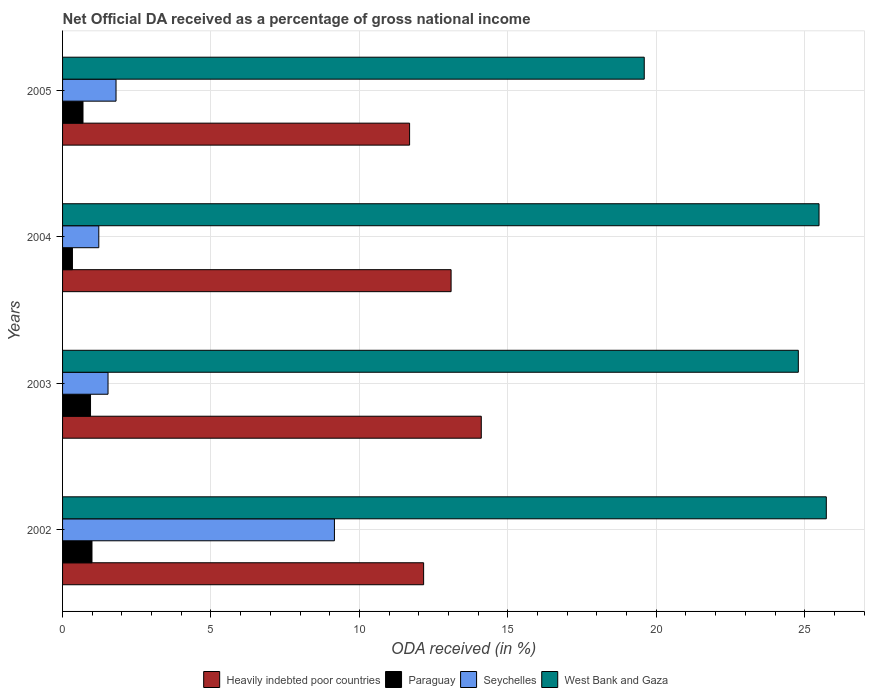How many different coloured bars are there?
Provide a succinct answer. 4. Are the number of bars per tick equal to the number of legend labels?
Offer a very short reply. Yes. Are the number of bars on each tick of the Y-axis equal?
Your answer should be compact. Yes. How many bars are there on the 4th tick from the top?
Provide a short and direct response. 4. In how many cases, is the number of bars for a given year not equal to the number of legend labels?
Make the answer very short. 0. What is the net official DA received in Heavily indebted poor countries in 2005?
Give a very brief answer. 11.69. Across all years, what is the maximum net official DA received in West Bank and Gaza?
Your response must be concise. 25.73. Across all years, what is the minimum net official DA received in Paraguay?
Your response must be concise. 0.33. In which year was the net official DA received in Heavily indebted poor countries maximum?
Your answer should be very brief. 2003. What is the total net official DA received in West Bank and Gaza in the graph?
Offer a terse response. 95.59. What is the difference between the net official DA received in Paraguay in 2002 and that in 2005?
Make the answer very short. 0.3. What is the difference between the net official DA received in West Bank and Gaza in 2004 and the net official DA received in Paraguay in 2003?
Ensure brevity in your answer.  24.54. What is the average net official DA received in Heavily indebted poor countries per year?
Make the answer very short. 12.76. In the year 2003, what is the difference between the net official DA received in Paraguay and net official DA received in Heavily indebted poor countries?
Offer a very short reply. -13.16. What is the ratio of the net official DA received in Paraguay in 2002 to that in 2004?
Your response must be concise. 2.98. Is the difference between the net official DA received in Paraguay in 2004 and 2005 greater than the difference between the net official DA received in Heavily indebted poor countries in 2004 and 2005?
Offer a terse response. No. What is the difference between the highest and the second highest net official DA received in Seychelles?
Give a very brief answer. 7.36. What is the difference between the highest and the lowest net official DA received in Heavily indebted poor countries?
Make the answer very short. 2.42. Is the sum of the net official DA received in Heavily indebted poor countries in 2003 and 2005 greater than the maximum net official DA received in West Bank and Gaza across all years?
Offer a very short reply. Yes. Is it the case that in every year, the sum of the net official DA received in Seychelles and net official DA received in Paraguay is greater than the sum of net official DA received in West Bank and Gaza and net official DA received in Heavily indebted poor countries?
Offer a terse response. No. What does the 2nd bar from the top in 2002 represents?
Make the answer very short. Seychelles. What does the 2nd bar from the bottom in 2004 represents?
Offer a very short reply. Paraguay. How many bars are there?
Provide a succinct answer. 16. How many years are there in the graph?
Make the answer very short. 4. What is the difference between two consecutive major ticks on the X-axis?
Ensure brevity in your answer.  5. Are the values on the major ticks of X-axis written in scientific E-notation?
Provide a succinct answer. No. Where does the legend appear in the graph?
Ensure brevity in your answer.  Bottom center. How many legend labels are there?
Provide a short and direct response. 4. What is the title of the graph?
Make the answer very short. Net Official DA received as a percentage of gross national income. Does "Cayman Islands" appear as one of the legend labels in the graph?
Your response must be concise. No. What is the label or title of the X-axis?
Provide a succinct answer. ODA received (in %). What is the ODA received (in %) of Heavily indebted poor countries in 2002?
Provide a succinct answer. 12.16. What is the ODA received (in %) in Paraguay in 2002?
Give a very brief answer. 0.99. What is the ODA received (in %) of Seychelles in 2002?
Give a very brief answer. 9.16. What is the ODA received (in %) of West Bank and Gaza in 2002?
Give a very brief answer. 25.73. What is the ODA received (in %) of Heavily indebted poor countries in 2003?
Make the answer very short. 14.11. What is the ODA received (in %) in Paraguay in 2003?
Offer a very short reply. 0.94. What is the ODA received (in %) of Seychelles in 2003?
Your answer should be compact. 1.53. What is the ODA received (in %) of West Bank and Gaza in 2003?
Provide a succinct answer. 24.79. What is the ODA received (in %) of Heavily indebted poor countries in 2004?
Ensure brevity in your answer.  13.09. What is the ODA received (in %) of Paraguay in 2004?
Your answer should be very brief. 0.33. What is the ODA received (in %) of Seychelles in 2004?
Offer a terse response. 1.22. What is the ODA received (in %) of West Bank and Gaza in 2004?
Make the answer very short. 25.48. What is the ODA received (in %) in Heavily indebted poor countries in 2005?
Keep it short and to the point. 11.69. What is the ODA received (in %) in Paraguay in 2005?
Offer a terse response. 0.69. What is the ODA received (in %) of Seychelles in 2005?
Your answer should be compact. 1.8. What is the ODA received (in %) in West Bank and Gaza in 2005?
Give a very brief answer. 19.6. Across all years, what is the maximum ODA received (in %) of Heavily indebted poor countries?
Provide a succinct answer. 14.11. Across all years, what is the maximum ODA received (in %) of Paraguay?
Provide a short and direct response. 0.99. Across all years, what is the maximum ODA received (in %) of Seychelles?
Your answer should be compact. 9.16. Across all years, what is the maximum ODA received (in %) in West Bank and Gaza?
Your answer should be very brief. 25.73. Across all years, what is the minimum ODA received (in %) in Heavily indebted poor countries?
Your answer should be compact. 11.69. Across all years, what is the minimum ODA received (in %) of Paraguay?
Make the answer very short. 0.33. Across all years, what is the minimum ODA received (in %) in Seychelles?
Ensure brevity in your answer.  1.22. Across all years, what is the minimum ODA received (in %) in West Bank and Gaza?
Provide a short and direct response. 19.6. What is the total ODA received (in %) in Heavily indebted poor countries in the graph?
Your response must be concise. 51.05. What is the total ODA received (in %) of Paraguay in the graph?
Provide a succinct answer. 2.95. What is the total ODA received (in %) of Seychelles in the graph?
Offer a terse response. 13.71. What is the total ODA received (in %) of West Bank and Gaza in the graph?
Your answer should be compact. 95.59. What is the difference between the ODA received (in %) of Heavily indebted poor countries in 2002 and that in 2003?
Provide a succinct answer. -1.94. What is the difference between the ODA received (in %) in Paraguay in 2002 and that in 2003?
Keep it short and to the point. 0.05. What is the difference between the ODA received (in %) in Seychelles in 2002 and that in 2003?
Provide a succinct answer. 7.63. What is the difference between the ODA received (in %) in West Bank and Gaza in 2002 and that in 2003?
Your answer should be very brief. 0.94. What is the difference between the ODA received (in %) of Heavily indebted poor countries in 2002 and that in 2004?
Your response must be concise. -0.93. What is the difference between the ODA received (in %) in Paraguay in 2002 and that in 2004?
Provide a succinct answer. 0.66. What is the difference between the ODA received (in %) in Seychelles in 2002 and that in 2004?
Ensure brevity in your answer.  7.94. What is the difference between the ODA received (in %) of West Bank and Gaza in 2002 and that in 2004?
Provide a short and direct response. 0.25. What is the difference between the ODA received (in %) of Heavily indebted poor countries in 2002 and that in 2005?
Keep it short and to the point. 0.47. What is the difference between the ODA received (in %) of Paraguay in 2002 and that in 2005?
Make the answer very short. 0.3. What is the difference between the ODA received (in %) in Seychelles in 2002 and that in 2005?
Offer a very short reply. 7.36. What is the difference between the ODA received (in %) of West Bank and Gaza in 2002 and that in 2005?
Offer a terse response. 6.13. What is the difference between the ODA received (in %) in Heavily indebted poor countries in 2003 and that in 2004?
Offer a very short reply. 1.02. What is the difference between the ODA received (in %) in Paraguay in 2003 and that in 2004?
Make the answer very short. 0.61. What is the difference between the ODA received (in %) of Seychelles in 2003 and that in 2004?
Your answer should be compact. 0.31. What is the difference between the ODA received (in %) in West Bank and Gaza in 2003 and that in 2004?
Give a very brief answer. -0.7. What is the difference between the ODA received (in %) in Heavily indebted poor countries in 2003 and that in 2005?
Offer a terse response. 2.42. What is the difference between the ODA received (in %) of Paraguay in 2003 and that in 2005?
Keep it short and to the point. 0.25. What is the difference between the ODA received (in %) in Seychelles in 2003 and that in 2005?
Offer a very short reply. -0.27. What is the difference between the ODA received (in %) in West Bank and Gaza in 2003 and that in 2005?
Ensure brevity in your answer.  5.19. What is the difference between the ODA received (in %) of Heavily indebted poor countries in 2004 and that in 2005?
Provide a short and direct response. 1.4. What is the difference between the ODA received (in %) of Paraguay in 2004 and that in 2005?
Ensure brevity in your answer.  -0.36. What is the difference between the ODA received (in %) in Seychelles in 2004 and that in 2005?
Ensure brevity in your answer.  -0.58. What is the difference between the ODA received (in %) of West Bank and Gaza in 2004 and that in 2005?
Provide a succinct answer. 5.89. What is the difference between the ODA received (in %) of Heavily indebted poor countries in 2002 and the ODA received (in %) of Paraguay in 2003?
Provide a succinct answer. 11.22. What is the difference between the ODA received (in %) of Heavily indebted poor countries in 2002 and the ODA received (in %) of Seychelles in 2003?
Ensure brevity in your answer.  10.63. What is the difference between the ODA received (in %) in Heavily indebted poor countries in 2002 and the ODA received (in %) in West Bank and Gaza in 2003?
Make the answer very short. -12.62. What is the difference between the ODA received (in %) in Paraguay in 2002 and the ODA received (in %) in Seychelles in 2003?
Give a very brief answer. -0.54. What is the difference between the ODA received (in %) of Paraguay in 2002 and the ODA received (in %) of West Bank and Gaza in 2003?
Keep it short and to the point. -23.79. What is the difference between the ODA received (in %) in Seychelles in 2002 and the ODA received (in %) in West Bank and Gaza in 2003?
Provide a short and direct response. -15.63. What is the difference between the ODA received (in %) of Heavily indebted poor countries in 2002 and the ODA received (in %) of Paraguay in 2004?
Offer a terse response. 11.83. What is the difference between the ODA received (in %) in Heavily indebted poor countries in 2002 and the ODA received (in %) in Seychelles in 2004?
Provide a succinct answer. 10.94. What is the difference between the ODA received (in %) in Heavily indebted poor countries in 2002 and the ODA received (in %) in West Bank and Gaza in 2004?
Offer a terse response. -13.32. What is the difference between the ODA received (in %) in Paraguay in 2002 and the ODA received (in %) in Seychelles in 2004?
Provide a short and direct response. -0.23. What is the difference between the ODA received (in %) in Paraguay in 2002 and the ODA received (in %) in West Bank and Gaza in 2004?
Give a very brief answer. -24.49. What is the difference between the ODA received (in %) of Seychelles in 2002 and the ODA received (in %) of West Bank and Gaza in 2004?
Offer a very short reply. -16.32. What is the difference between the ODA received (in %) in Heavily indebted poor countries in 2002 and the ODA received (in %) in Paraguay in 2005?
Your answer should be very brief. 11.47. What is the difference between the ODA received (in %) of Heavily indebted poor countries in 2002 and the ODA received (in %) of Seychelles in 2005?
Your answer should be very brief. 10.36. What is the difference between the ODA received (in %) in Heavily indebted poor countries in 2002 and the ODA received (in %) in West Bank and Gaza in 2005?
Make the answer very short. -7.43. What is the difference between the ODA received (in %) in Paraguay in 2002 and the ODA received (in %) in Seychelles in 2005?
Provide a short and direct response. -0.81. What is the difference between the ODA received (in %) of Paraguay in 2002 and the ODA received (in %) of West Bank and Gaza in 2005?
Your answer should be compact. -18.6. What is the difference between the ODA received (in %) in Seychelles in 2002 and the ODA received (in %) in West Bank and Gaza in 2005?
Make the answer very short. -10.44. What is the difference between the ODA received (in %) in Heavily indebted poor countries in 2003 and the ODA received (in %) in Paraguay in 2004?
Give a very brief answer. 13.77. What is the difference between the ODA received (in %) of Heavily indebted poor countries in 2003 and the ODA received (in %) of Seychelles in 2004?
Your answer should be very brief. 12.88. What is the difference between the ODA received (in %) of Heavily indebted poor countries in 2003 and the ODA received (in %) of West Bank and Gaza in 2004?
Offer a terse response. -11.38. What is the difference between the ODA received (in %) of Paraguay in 2003 and the ODA received (in %) of Seychelles in 2004?
Your answer should be compact. -0.28. What is the difference between the ODA received (in %) in Paraguay in 2003 and the ODA received (in %) in West Bank and Gaza in 2004?
Provide a short and direct response. -24.54. What is the difference between the ODA received (in %) of Seychelles in 2003 and the ODA received (in %) of West Bank and Gaza in 2004?
Provide a short and direct response. -23.95. What is the difference between the ODA received (in %) in Heavily indebted poor countries in 2003 and the ODA received (in %) in Paraguay in 2005?
Give a very brief answer. 13.42. What is the difference between the ODA received (in %) of Heavily indebted poor countries in 2003 and the ODA received (in %) of Seychelles in 2005?
Your answer should be very brief. 12.3. What is the difference between the ODA received (in %) of Heavily indebted poor countries in 2003 and the ODA received (in %) of West Bank and Gaza in 2005?
Make the answer very short. -5.49. What is the difference between the ODA received (in %) of Paraguay in 2003 and the ODA received (in %) of Seychelles in 2005?
Give a very brief answer. -0.86. What is the difference between the ODA received (in %) in Paraguay in 2003 and the ODA received (in %) in West Bank and Gaza in 2005?
Offer a terse response. -18.65. What is the difference between the ODA received (in %) of Seychelles in 2003 and the ODA received (in %) of West Bank and Gaza in 2005?
Your answer should be compact. -18.06. What is the difference between the ODA received (in %) of Heavily indebted poor countries in 2004 and the ODA received (in %) of Paraguay in 2005?
Your response must be concise. 12.4. What is the difference between the ODA received (in %) in Heavily indebted poor countries in 2004 and the ODA received (in %) in Seychelles in 2005?
Offer a very short reply. 11.29. What is the difference between the ODA received (in %) of Heavily indebted poor countries in 2004 and the ODA received (in %) of West Bank and Gaza in 2005?
Your answer should be very brief. -6.51. What is the difference between the ODA received (in %) in Paraguay in 2004 and the ODA received (in %) in Seychelles in 2005?
Provide a succinct answer. -1.47. What is the difference between the ODA received (in %) in Paraguay in 2004 and the ODA received (in %) in West Bank and Gaza in 2005?
Make the answer very short. -19.26. What is the difference between the ODA received (in %) in Seychelles in 2004 and the ODA received (in %) in West Bank and Gaza in 2005?
Provide a short and direct response. -18.37. What is the average ODA received (in %) of Heavily indebted poor countries per year?
Your answer should be very brief. 12.76. What is the average ODA received (in %) of Paraguay per year?
Provide a succinct answer. 0.74. What is the average ODA received (in %) in Seychelles per year?
Ensure brevity in your answer.  3.43. What is the average ODA received (in %) of West Bank and Gaza per year?
Offer a very short reply. 23.9. In the year 2002, what is the difference between the ODA received (in %) in Heavily indebted poor countries and ODA received (in %) in Paraguay?
Your answer should be very brief. 11.17. In the year 2002, what is the difference between the ODA received (in %) of Heavily indebted poor countries and ODA received (in %) of Seychelles?
Offer a very short reply. 3. In the year 2002, what is the difference between the ODA received (in %) of Heavily indebted poor countries and ODA received (in %) of West Bank and Gaza?
Ensure brevity in your answer.  -13.57. In the year 2002, what is the difference between the ODA received (in %) in Paraguay and ODA received (in %) in Seychelles?
Ensure brevity in your answer.  -8.17. In the year 2002, what is the difference between the ODA received (in %) of Paraguay and ODA received (in %) of West Bank and Gaza?
Provide a short and direct response. -24.74. In the year 2002, what is the difference between the ODA received (in %) in Seychelles and ODA received (in %) in West Bank and Gaza?
Give a very brief answer. -16.57. In the year 2003, what is the difference between the ODA received (in %) in Heavily indebted poor countries and ODA received (in %) in Paraguay?
Give a very brief answer. 13.16. In the year 2003, what is the difference between the ODA received (in %) of Heavily indebted poor countries and ODA received (in %) of Seychelles?
Make the answer very short. 12.57. In the year 2003, what is the difference between the ODA received (in %) of Heavily indebted poor countries and ODA received (in %) of West Bank and Gaza?
Give a very brief answer. -10.68. In the year 2003, what is the difference between the ODA received (in %) in Paraguay and ODA received (in %) in Seychelles?
Keep it short and to the point. -0.59. In the year 2003, what is the difference between the ODA received (in %) of Paraguay and ODA received (in %) of West Bank and Gaza?
Offer a very short reply. -23.84. In the year 2003, what is the difference between the ODA received (in %) in Seychelles and ODA received (in %) in West Bank and Gaza?
Your response must be concise. -23.25. In the year 2004, what is the difference between the ODA received (in %) of Heavily indebted poor countries and ODA received (in %) of Paraguay?
Keep it short and to the point. 12.76. In the year 2004, what is the difference between the ODA received (in %) of Heavily indebted poor countries and ODA received (in %) of Seychelles?
Offer a very short reply. 11.87. In the year 2004, what is the difference between the ODA received (in %) in Heavily indebted poor countries and ODA received (in %) in West Bank and Gaza?
Ensure brevity in your answer.  -12.39. In the year 2004, what is the difference between the ODA received (in %) of Paraguay and ODA received (in %) of Seychelles?
Provide a succinct answer. -0.89. In the year 2004, what is the difference between the ODA received (in %) in Paraguay and ODA received (in %) in West Bank and Gaza?
Keep it short and to the point. -25.15. In the year 2004, what is the difference between the ODA received (in %) of Seychelles and ODA received (in %) of West Bank and Gaza?
Your answer should be very brief. -24.26. In the year 2005, what is the difference between the ODA received (in %) in Heavily indebted poor countries and ODA received (in %) in Paraguay?
Your answer should be compact. 11. In the year 2005, what is the difference between the ODA received (in %) of Heavily indebted poor countries and ODA received (in %) of Seychelles?
Make the answer very short. 9.89. In the year 2005, what is the difference between the ODA received (in %) in Heavily indebted poor countries and ODA received (in %) in West Bank and Gaza?
Provide a succinct answer. -7.91. In the year 2005, what is the difference between the ODA received (in %) in Paraguay and ODA received (in %) in Seychelles?
Your response must be concise. -1.11. In the year 2005, what is the difference between the ODA received (in %) in Paraguay and ODA received (in %) in West Bank and Gaza?
Offer a terse response. -18.91. In the year 2005, what is the difference between the ODA received (in %) in Seychelles and ODA received (in %) in West Bank and Gaza?
Your answer should be very brief. -17.79. What is the ratio of the ODA received (in %) of Heavily indebted poor countries in 2002 to that in 2003?
Provide a succinct answer. 0.86. What is the ratio of the ODA received (in %) of Paraguay in 2002 to that in 2003?
Your response must be concise. 1.05. What is the ratio of the ODA received (in %) of Seychelles in 2002 to that in 2003?
Ensure brevity in your answer.  5.98. What is the ratio of the ODA received (in %) of West Bank and Gaza in 2002 to that in 2003?
Make the answer very short. 1.04. What is the ratio of the ODA received (in %) in Heavily indebted poor countries in 2002 to that in 2004?
Provide a short and direct response. 0.93. What is the ratio of the ODA received (in %) in Paraguay in 2002 to that in 2004?
Provide a short and direct response. 2.98. What is the ratio of the ODA received (in %) in Seychelles in 2002 to that in 2004?
Your response must be concise. 7.5. What is the ratio of the ODA received (in %) in West Bank and Gaza in 2002 to that in 2004?
Offer a terse response. 1.01. What is the ratio of the ODA received (in %) of Heavily indebted poor countries in 2002 to that in 2005?
Provide a short and direct response. 1.04. What is the ratio of the ODA received (in %) in Paraguay in 2002 to that in 2005?
Offer a terse response. 1.44. What is the ratio of the ODA received (in %) in Seychelles in 2002 to that in 2005?
Ensure brevity in your answer.  5.08. What is the ratio of the ODA received (in %) of West Bank and Gaza in 2002 to that in 2005?
Your answer should be compact. 1.31. What is the ratio of the ODA received (in %) of Heavily indebted poor countries in 2003 to that in 2004?
Your answer should be compact. 1.08. What is the ratio of the ODA received (in %) of Paraguay in 2003 to that in 2004?
Give a very brief answer. 2.83. What is the ratio of the ODA received (in %) of Seychelles in 2003 to that in 2004?
Your answer should be compact. 1.25. What is the ratio of the ODA received (in %) of West Bank and Gaza in 2003 to that in 2004?
Provide a succinct answer. 0.97. What is the ratio of the ODA received (in %) in Heavily indebted poor countries in 2003 to that in 2005?
Provide a short and direct response. 1.21. What is the ratio of the ODA received (in %) in Paraguay in 2003 to that in 2005?
Your answer should be very brief. 1.37. What is the ratio of the ODA received (in %) of Seychelles in 2003 to that in 2005?
Offer a terse response. 0.85. What is the ratio of the ODA received (in %) in West Bank and Gaza in 2003 to that in 2005?
Ensure brevity in your answer.  1.26. What is the ratio of the ODA received (in %) of Heavily indebted poor countries in 2004 to that in 2005?
Ensure brevity in your answer.  1.12. What is the ratio of the ODA received (in %) in Paraguay in 2004 to that in 2005?
Make the answer very short. 0.48. What is the ratio of the ODA received (in %) of Seychelles in 2004 to that in 2005?
Your answer should be very brief. 0.68. What is the ratio of the ODA received (in %) in West Bank and Gaza in 2004 to that in 2005?
Offer a very short reply. 1.3. What is the difference between the highest and the second highest ODA received (in %) of Heavily indebted poor countries?
Ensure brevity in your answer.  1.02. What is the difference between the highest and the second highest ODA received (in %) of Paraguay?
Your answer should be very brief. 0.05. What is the difference between the highest and the second highest ODA received (in %) of Seychelles?
Your answer should be very brief. 7.36. What is the difference between the highest and the second highest ODA received (in %) in West Bank and Gaza?
Offer a very short reply. 0.25. What is the difference between the highest and the lowest ODA received (in %) of Heavily indebted poor countries?
Keep it short and to the point. 2.42. What is the difference between the highest and the lowest ODA received (in %) in Paraguay?
Ensure brevity in your answer.  0.66. What is the difference between the highest and the lowest ODA received (in %) of Seychelles?
Provide a short and direct response. 7.94. What is the difference between the highest and the lowest ODA received (in %) in West Bank and Gaza?
Provide a succinct answer. 6.13. 